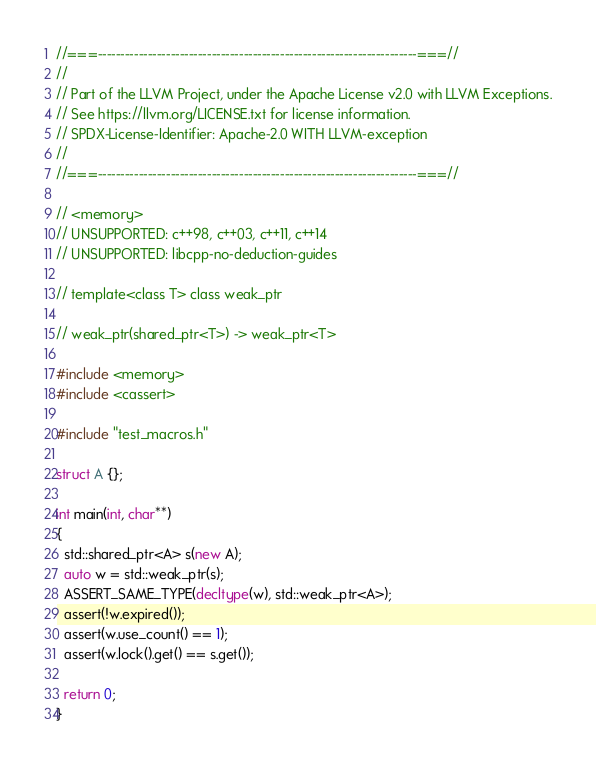<code> <loc_0><loc_0><loc_500><loc_500><_C++_>//===----------------------------------------------------------------------===//
//
// Part of the LLVM Project, under the Apache License v2.0 with LLVM Exceptions.
// See https://llvm.org/LICENSE.txt for license information.
// SPDX-License-Identifier: Apache-2.0 WITH LLVM-exception
//
//===----------------------------------------------------------------------===//

// <memory>
// UNSUPPORTED: c++98, c++03, c++11, c++14
// UNSUPPORTED: libcpp-no-deduction-guides

// template<class T> class weak_ptr

// weak_ptr(shared_ptr<T>) -> weak_ptr<T>

#include <memory>
#include <cassert>

#include "test_macros.h"

struct A {};

int main(int, char**)
{
  std::shared_ptr<A> s(new A);
  auto w = std::weak_ptr(s);
  ASSERT_SAME_TYPE(decltype(w), std::weak_ptr<A>);
  assert(!w.expired());
  assert(w.use_count() == 1);
  assert(w.lock().get() == s.get());

  return 0;
}
</code> 